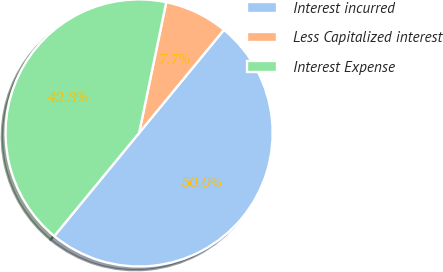Convert chart. <chart><loc_0><loc_0><loc_500><loc_500><pie_chart><fcel>Interest incurred<fcel>Less Capitalized interest<fcel>Interest Expense<nl><fcel>50.0%<fcel>7.7%<fcel>42.3%<nl></chart> 